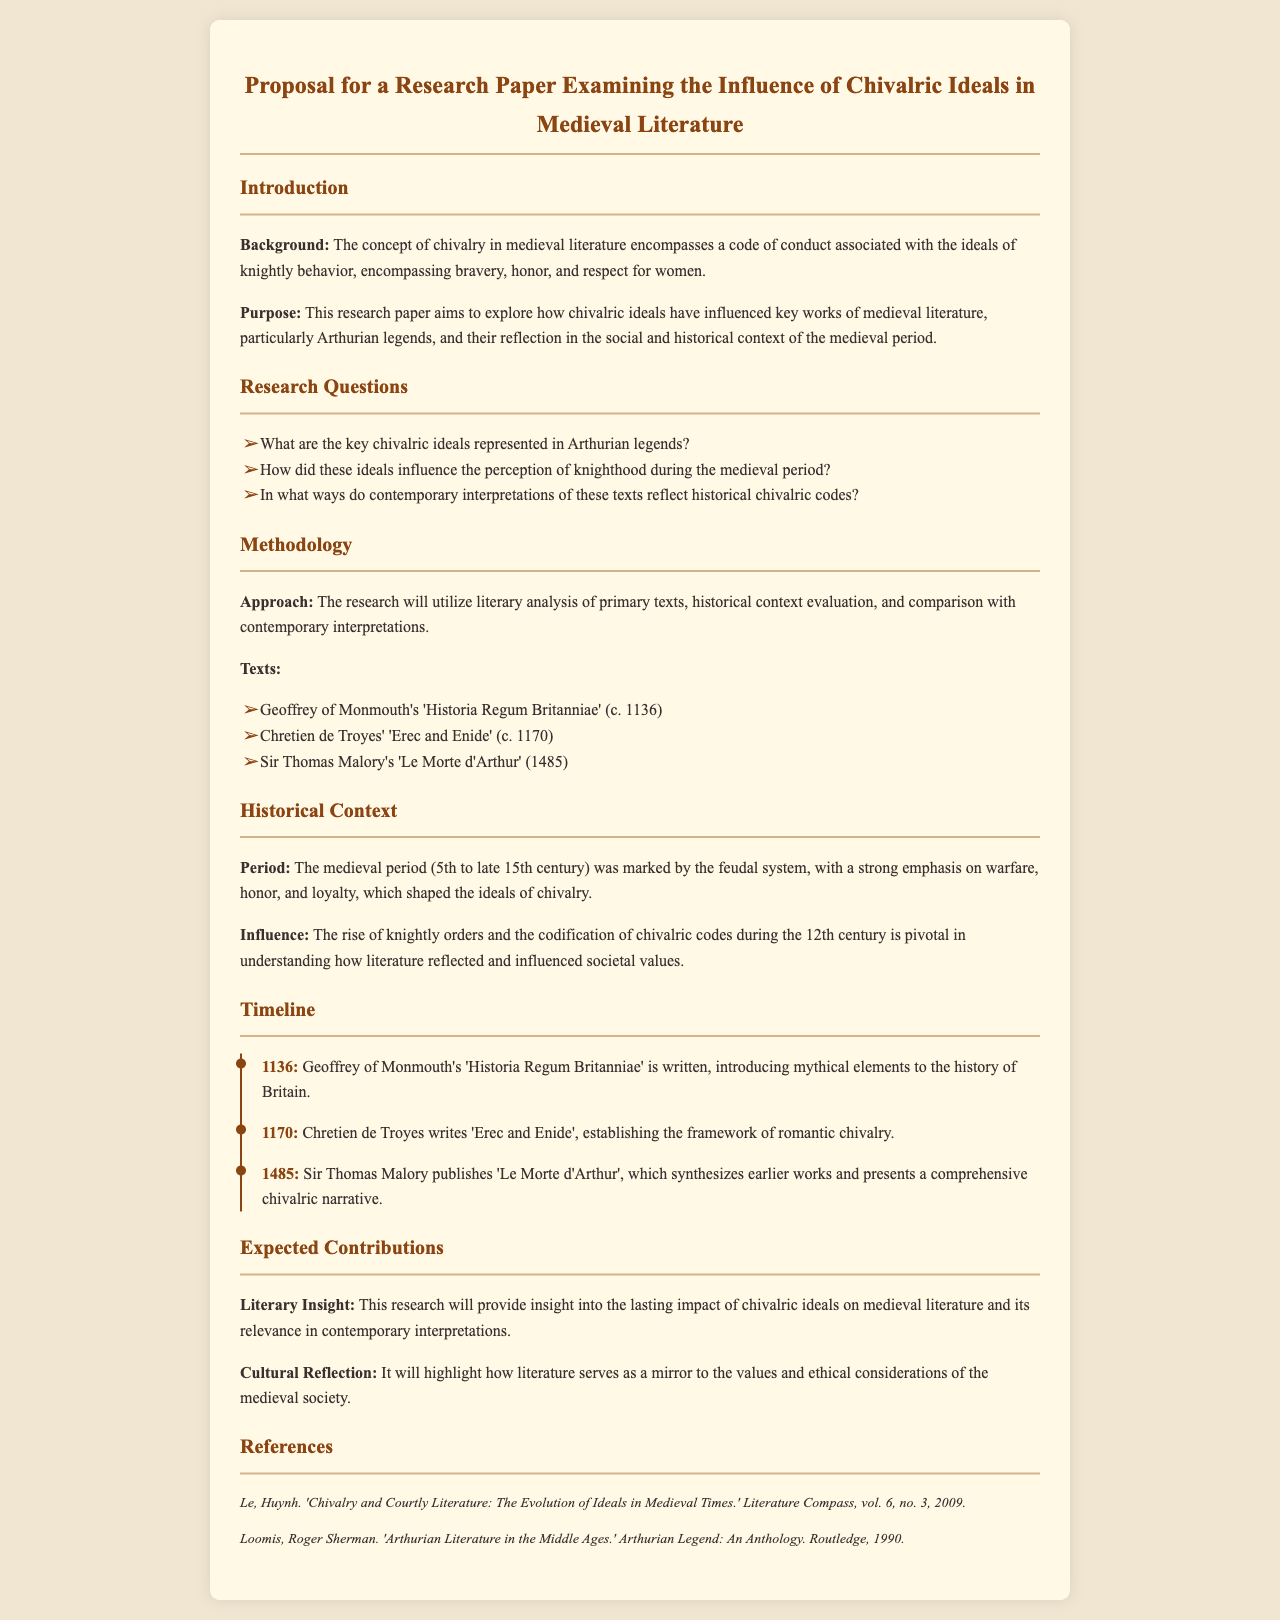What is the title of the research paper? The title is clearly mentioned at the top of the document, which is a proposal for a research paper examining the influence of chivalric ideals in medieval literature.
Answer: Proposal for a Research Paper Examining the Influence of Chivalric Ideals in Medieval Literature Who authored 'Le Morte d'Arthur'? The document lists Sir Thomas Malory as the author of 'Le Morte d'Arthur' under the methodology section.
Answer: Sir Thomas Malory What year was 'Historia Regum Britanniae' written? The timeline lists 1136 as the year Geoffrey of Monmouth wrote 'Historia Regum Britanniae'.
Answer: 1136 What is one key research question? The document provides several research questions specifically listed in the research questions section, one of which is about key chivalric ideals.
Answer: What are the key chivalric ideals represented in Arthurian legends? What is the focus of the expected contributions section? The expected contributions section outlines insights into the lasting impact of chivalric ideals and highlights cultural reflections, thus providing insights into literature's impact.
Answer: Literary Insight What period does the document highlight for historical context? The historical context section specifies the medieval period ranging from the 5th to the late 15th century.
Answer: 5th to late 15th century Which text is noted for establishing the framework of romantic chivalry? The document identifies 'Erec and Enide' by Chretien de Troyes as the text that establishes the framework of romantic chivalry.
Answer: 'Erec and Enide' What element does the timeline feature? The timeline features significant historical events alongside the corresponding years of relevant medieval literary texts.
Answer: Significant historical events 